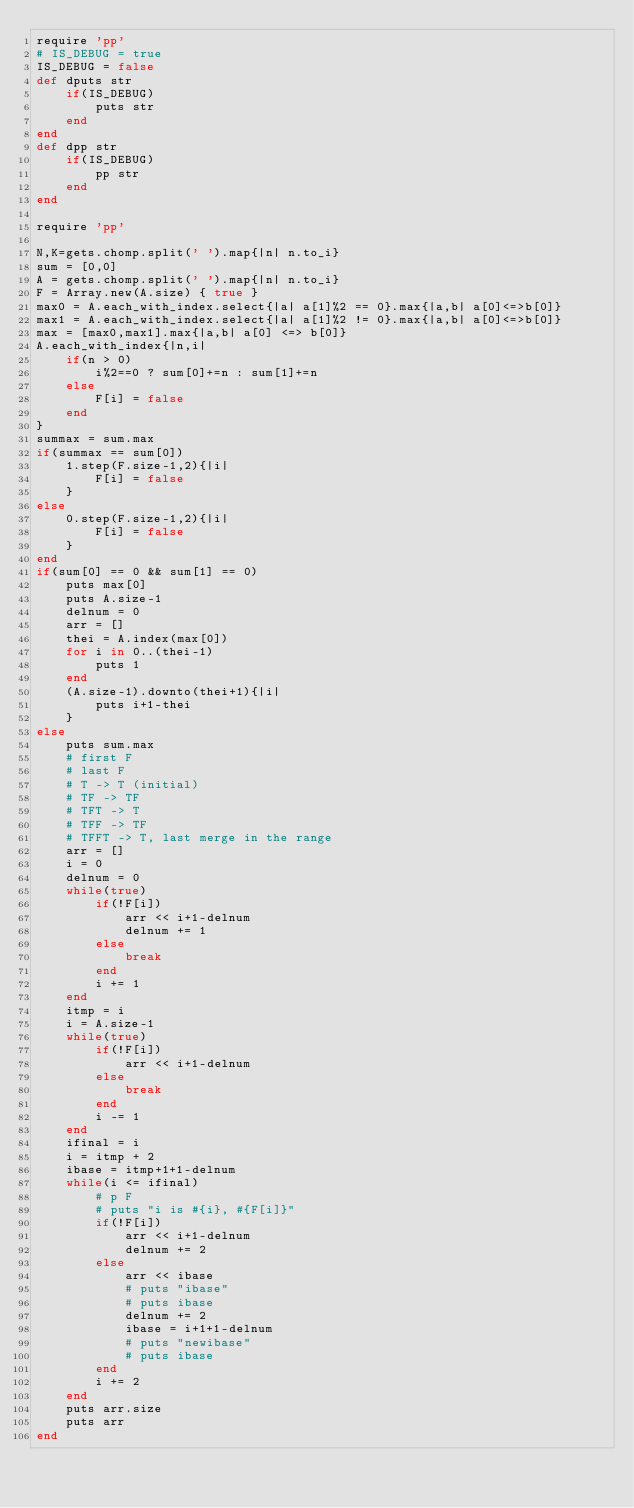<code> <loc_0><loc_0><loc_500><loc_500><_Ruby_>require 'pp'
# IS_DEBUG = true
IS_DEBUG = false
def dputs str
	if(IS_DEBUG)
		puts str
	end
end
def dpp str
	if(IS_DEBUG)
		pp str
	end
end

require 'pp'

N,K=gets.chomp.split(' ').map{|n| n.to_i}
sum = [0,0]
A = gets.chomp.split(' ').map{|n| n.to_i}
F = Array.new(A.size) { true }
max0 = A.each_with_index.select{|a| a[1]%2 == 0}.max{|a,b| a[0]<=>b[0]}
max1 = A.each_with_index.select{|a| a[1]%2 != 0}.max{|a,b| a[0]<=>b[0]}
max = [max0,max1].max{|a,b| a[0] <=> b[0]}
A.each_with_index{|n,i|
	if(n > 0)
		i%2==0 ? sum[0]+=n : sum[1]+=n
	else
		F[i] = false
	end
}
summax = sum.max
if(summax == sum[0])
	1.step(F.size-1,2){|i|
		F[i] = false
	}
else
	0.step(F.size-1,2){|i|
		F[i] = false
	}
end
if(sum[0] == 0 && sum[1] == 0)
	puts max[0]
	puts A.size-1
	delnum = 0
	arr = []
	thei = A.index(max[0])
	for i in 0..(thei-1)
		puts 1
	end
	(A.size-1).downto(thei+1){|i|
		puts i+1-thei
	}
else
	puts sum.max
	# first F
	# last F
	# T -> T (initial)
	# TF -> TF
	# TFT -> T
	# TFF -> TF
	# TFFT -> T, last merge in the range
	arr = []
	i = 0
	delnum = 0
	while(true)
		if(!F[i])
			arr << i+1-delnum
			delnum += 1
		else
			break
		end
		i += 1
	end
	itmp = i
	i = A.size-1
	while(true)
		if(!F[i])
			arr << i+1-delnum
		else
			break
		end
		i -= 1
	end
	ifinal = i
	i = itmp + 2
	ibase = itmp+1+1-delnum
	while(i <= ifinal)
		# p F
		# puts "i is #{i}, #{F[i]}"
		if(!F[i])
			arr << i+1-delnum
			delnum += 2
		else
			arr << ibase
			# puts "ibase"
			# puts ibase
			delnum += 2
			ibase = i+1+1-delnum
			# puts "newibase"
			# puts ibase
		end
		i += 2
	end	
	puts arr.size
	puts arr
end

</code> 